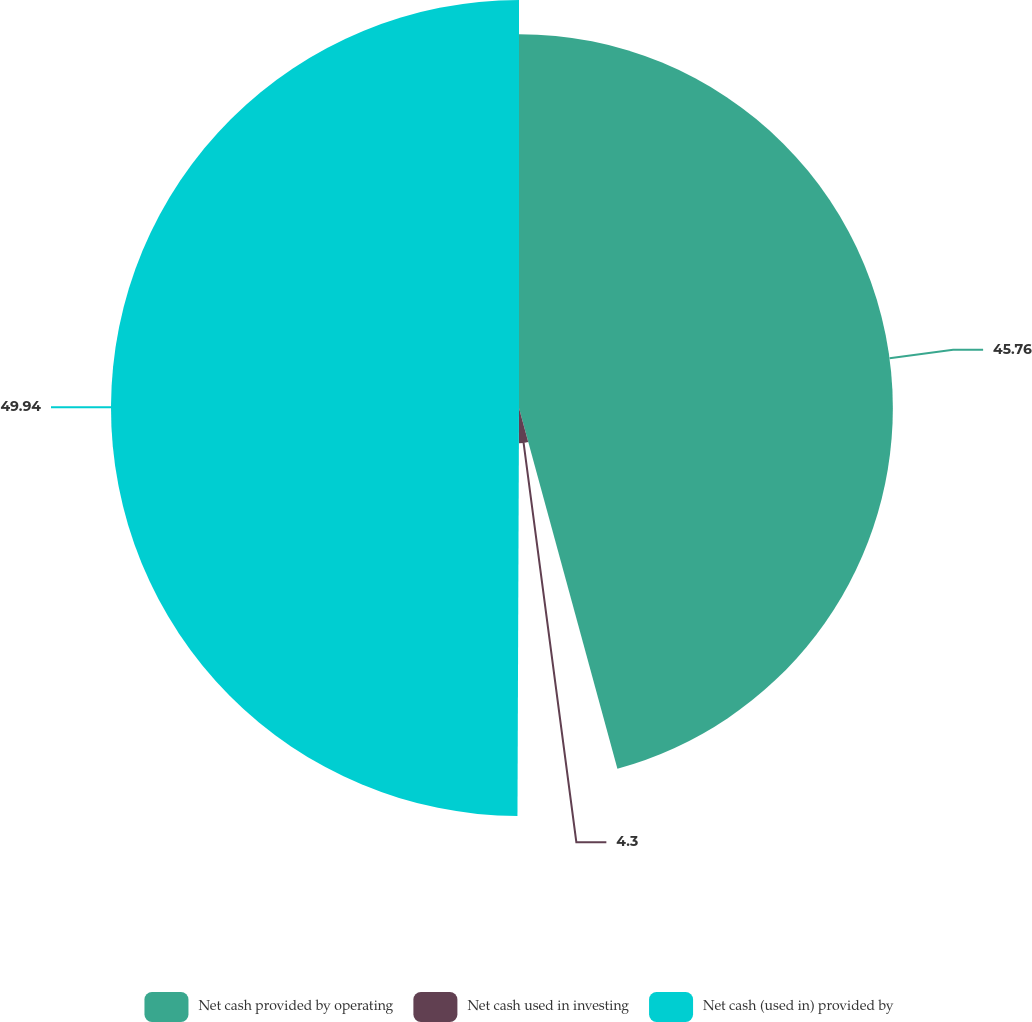<chart> <loc_0><loc_0><loc_500><loc_500><pie_chart><fcel>Net cash provided by operating<fcel>Net cash used in investing<fcel>Net cash (used in) provided by<nl><fcel>45.76%<fcel>4.3%<fcel>49.94%<nl></chart> 